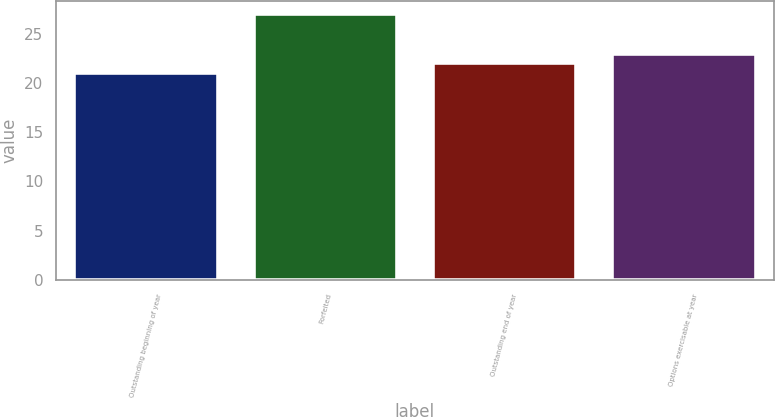Convert chart to OTSL. <chart><loc_0><loc_0><loc_500><loc_500><bar_chart><fcel>Outstanding beginning of year<fcel>Forfeited<fcel>Outstanding end of year<fcel>Options exercisable at year<nl><fcel>21<fcel>27<fcel>22<fcel>23<nl></chart> 